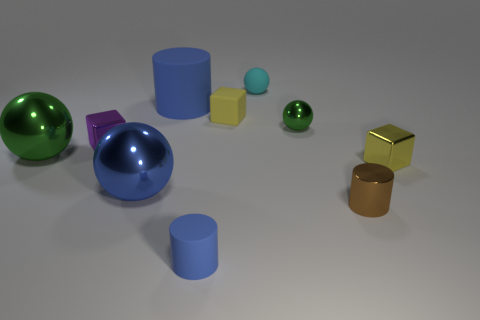What is the shape of the blue rubber thing in front of the yellow thing left of the tiny green metallic sphere?
Keep it short and to the point. Cylinder. Does the large sphere that is in front of the big green metallic thing have the same material as the tiny green thing?
Provide a short and direct response. Yes. What number of green objects are either small things or tiny rubber cubes?
Offer a terse response. 1. Is there a thing that has the same color as the large rubber cylinder?
Offer a very short reply. Yes. Is there a small cyan thing made of the same material as the big cylinder?
Make the answer very short. Yes. There is a small thing that is both in front of the tiny yellow shiny cube and to the left of the cyan matte sphere; what is its shape?
Your answer should be very brief. Cylinder. How many big objects are blue shiny cylinders or purple cubes?
Offer a very short reply. 0. What is the material of the big cylinder?
Your answer should be very brief. Rubber. How many other objects are there of the same shape as the brown metallic thing?
Give a very brief answer. 2. What size is the blue metallic thing?
Provide a short and direct response. Large. 